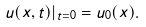<formula> <loc_0><loc_0><loc_500><loc_500>u ( x , t ) | _ { t = 0 } = u _ { 0 } ( x ) .</formula> 